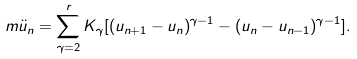Convert formula to latex. <formula><loc_0><loc_0><loc_500><loc_500>m \ddot { u } _ { n } = \sum _ { \gamma = 2 } ^ { r } K _ { \gamma } [ ( u _ { n + 1 } - u _ { n } ) ^ { \gamma - 1 } - ( u _ { n } - u _ { n - 1 } ) ^ { \gamma - 1 } ] .</formula> 